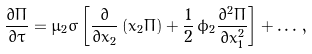Convert formula to latex. <formula><loc_0><loc_0><loc_500><loc_500>\frac { \partial \Pi } { \partial \tau } = \mu _ { 2 } \sigma \left [ \frac { \partial } { \partial x _ { 2 } } \left ( x _ { 2 } \Pi \right ) + \frac { 1 } { 2 } \, \phi _ { 2 } \frac { \partial ^ { 2 } \Pi } { \partial x _ { 1 } ^ { 2 } } \right ] + \dots \, ,</formula> 